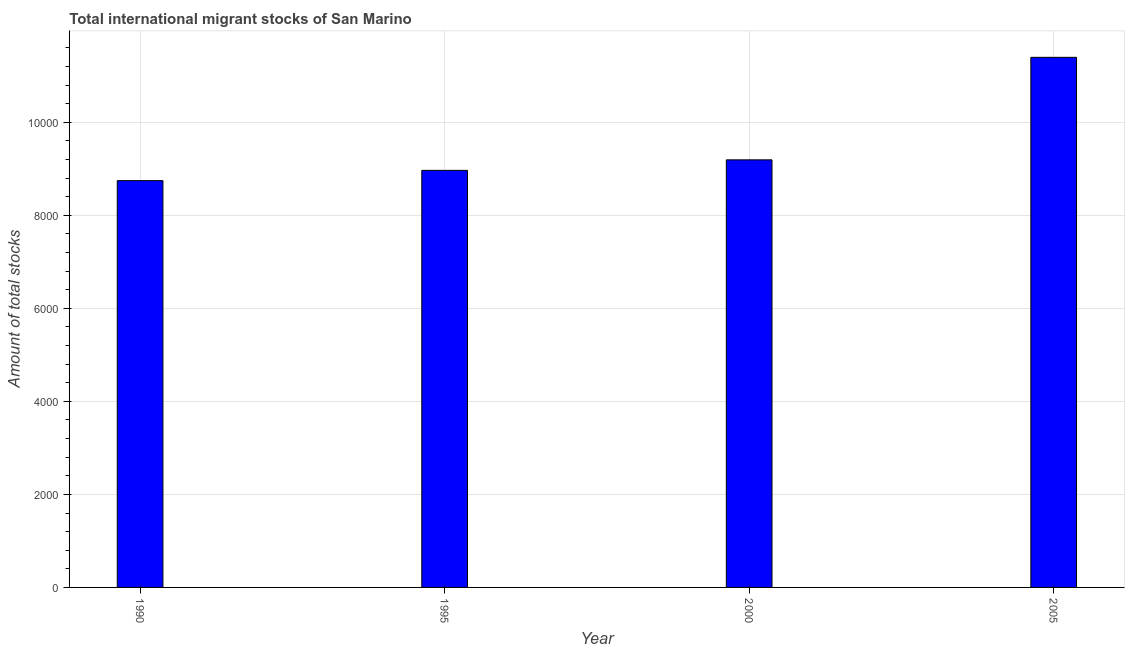Does the graph contain grids?
Provide a short and direct response. Yes. What is the title of the graph?
Offer a very short reply. Total international migrant stocks of San Marino. What is the label or title of the X-axis?
Offer a terse response. Year. What is the label or title of the Y-axis?
Provide a succinct answer. Amount of total stocks. What is the total number of international migrant stock in 2005?
Make the answer very short. 1.14e+04. Across all years, what is the maximum total number of international migrant stock?
Make the answer very short. 1.14e+04. Across all years, what is the minimum total number of international migrant stock?
Provide a short and direct response. 8745. In which year was the total number of international migrant stock minimum?
Your answer should be compact. 1990. What is the sum of the total number of international migrant stock?
Provide a succinct answer. 3.83e+04. What is the difference between the total number of international migrant stock in 1995 and 2000?
Your response must be concise. -226. What is the average total number of international migrant stock per year?
Your response must be concise. 9574. What is the median total number of international migrant stock?
Provide a succinct answer. 9079. Do a majority of the years between 2000 and 2005 (inclusive) have total number of international migrant stock greater than 400 ?
Your answer should be compact. Yes. What is the ratio of the total number of international migrant stock in 1990 to that in 2000?
Provide a short and direct response. 0.95. Is the difference between the total number of international migrant stock in 1995 and 2005 greater than the difference between any two years?
Offer a terse response. No. What is the difference between the highest and the second highest total number of international migrant stock?
Ensure brevity in your answer.  2204. What is the difference between the highest and the lowest total number of international migrant stock?
Offer a terse response. 2651. How many years are there in the graph?
Keep it short and to the point. 4. What is the difference between two consecutive major ticks on the Y-axis?
Your response must be concise. 2000. What is the Amount of total stocks in 1990?
Keep it short and to the point. 8745. What is the Amount of total stocks in 1995?
Provide a succinct answer. 8966. What is the Amount of total stocks in 2000?
Make the answer very short. 9192. What is the Amount of total stocks in 2005?
Your answer should be compact. 1.14e+04. What is the difference between the Amount of total stocks in 1990 and 1995?
Offer a terse response. -221. What is the difference between the Amount of total stocks in 1990 and 2000?
Keep it short and to the point. -447. What is the difference between the Amount of total stocks in 1990 and 2005?
Provide a succinct answer. -2651. What is the difference between the Amount of total stocks in 1995 and 2000?
Your answer should be very brief. -226. What is the difference between the Amount of total stocks in 1995 and 2005?
Provide a succinct answer. -2430. What is the difference between the Amount of total stocks in 2000 and 2005?
Give a very brief answer. -2204. What is the ratio of the Amount of total stocks in 1990 to that in 2000?
Provide a short and direct response. 0.95. What is the ratio of the Amount of total stocks in 1990 to that in 2005?
Offer a very short reply. 0.77. What is the ratio of the Amount of total stocks in 1995 to that in 2005?
Make the answer very short. 0.79. What is the ratio of the Amount of total stocks in 2000 to that in 2005?
Your response must be concise. 0.81. 